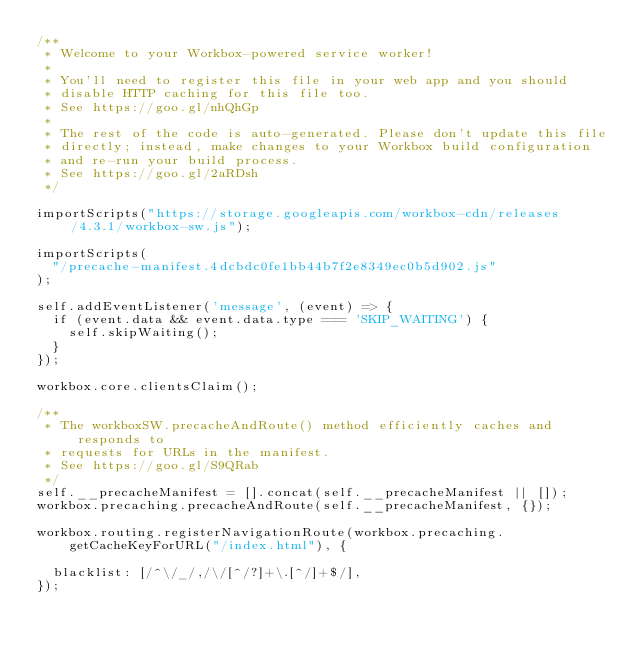<code> <loc_0><loc_0><loc_500><loc_500><_JavaScript_>/**
 * Welcome to your Workbox-powered service worker!
 *
 * You'll need to register this file in your web app and you should
 * disable HTTP caching for this file too.
 * See https://goo.gl/nhQhGp
 *
 * The rest of the code is auto-generated. Please don't update this file
 * directly; instead, make changes to your Workbox build configuration
 * and re-run your build process.
 * See https://goo.gl/2aRDsh
 */

importScripts("https://storage.googleapis.com/workbox-cdn/releases/4.3.1/workbox-sw.js");

importScripts(
  "/precache-manifest.4dcbdc0fe1bb44b7f2e8349ec0b5d902.js"
);

self.addEventListener('message', (event) => {
  if (event.data && event.data.type === 'SKIP_WAITING') {
    self.skipWaiting();
  }
});

workbox.core.clientsClaim();

/**
 * The workboxSW.precacheAndRoute() method efficiently caches and responds to
 * requests for URLs in the manifest.
 * See https://goo.gl/S9QRab
 */
self.__precacheManifest = [].concat(self.__precacheManifest || []);
workbox.precaching.precacheAndRoute(self.__precacheManifest, {});

workbox.routing.registerNavigationRoute(workbox.precaching.getCacheKeyForURL("/index.html"), {
  
  blacklist: [/^\/_/,/\/[^/?]+\.[^/]+$/],
});
</code> 